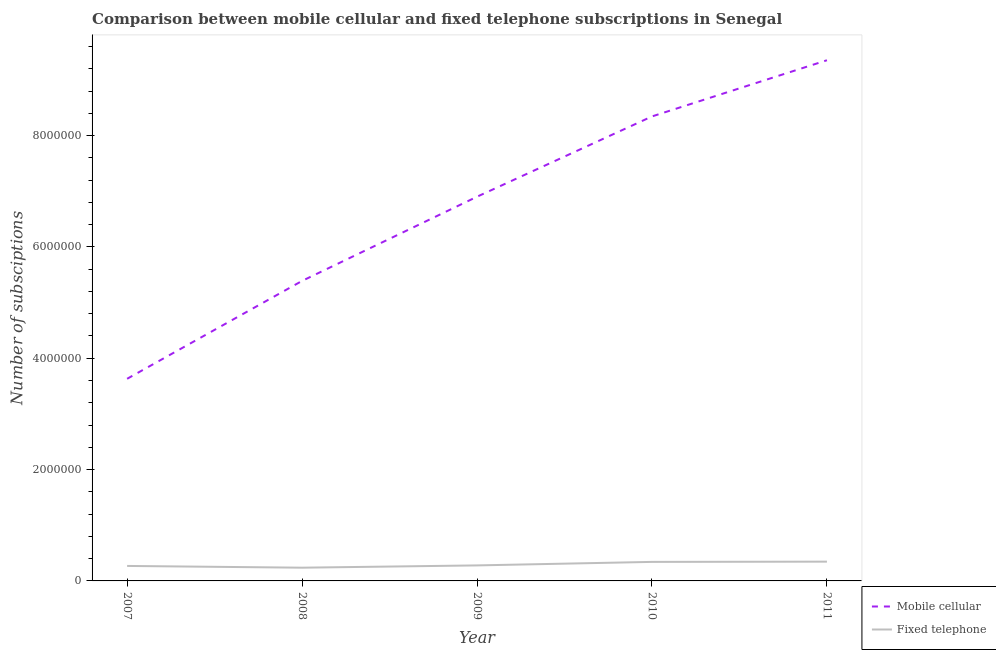How many different coloured lines are there?
Keep it short and to the point. 2. What is the number of fixed telephone subscriptions in 2010?
Give a very brief answer. 3.42e+05. Across all years, what is the maximum number of fixed telephone subscriptions?
Make the answer very short. 3.46e+05. Across all years, what is the minimum number of mobile cellular subscriptions?
Your answer should be very brief. 3.63e+06. In which year was the number of fixed telephone subscriptions minimum?
Your response must be concise. 2008. What is the total number of mobile cellular subscriptions in the graph?
Keep it short and to the point. 3.36e+07. What is the difference between the number of fixed telephone subscriptions in 2007 and that in 2011?
Make the answer very short. -7.73e+04. What is the difference between the number of mobile cellular subscriptions in 2011 and the number of fixed telephone subscriptions in 2009?
Give a very brief answer. 9.07e+06. What is the average number of fixed telephone subscriptions per year?
Give a very brief answer. 2.95e+05. In the year 2008, what is the difference between the number of fixed telephone subscriptions and number of mobile cellular subscriptions?
Give a very brief answer. -5.15e+06. In how many years, is the number of mobile cellular subscriptions greater than 8000000?
Your response must be concise. 2. What is the ratio of the number of mobile cellular subscriptions in 2008 to that in 2010?
Make the answer very short. 0.65. Is the number of mobile cellular subscriptions in 2007 less than that in 2008?
Keep it short and to the point. Yes. Is the difference between the number of mobile cellular subscriptions in 2007 and 2009 greater than the difference between the number of fixed telephone subscriptions in 2007 and 2009?
Your answer should be compact. No. What is the difference between the highest and the second highest number of mobile cellular subscriptions?
Ensure brevity in your answer.  1.01e+06. What is the difference between the highest and the lowest number of mobile cellular subscriptions?
Provide a short and direct response. 5.72e+06. Is the sum of the number of mobile cellular subscriptions in 2009 and 2011 greater than the maximum number of fixed telephone subscriptions across all years?
Your answer should be compact. Yes. Does the number of mobile cellular subscriptions monotonically increase over the years?
Your answer should be very brief. Yes. Is the number of fixed telephone subscriptions strictly greater than the number of mobile cellular subscriptions over the years?
Provide a succinct answer. No. How many lines are there?
Offer a terse response. 2. Does the graph contain any zero values?
Your answer should be very brief. No. Does the graph contain grids?
Give a very brief answer. No. What is the title of the graph?
Give a very brief answer. Comparison between mobile cellular and fixed telephone subscriptions in Senegal. What is the label or title of the X-axis?
Your answer should be compact. Year. What is the label or title of the Y-axis?
Offer a terse response. Number of subsciptions. What is the Number of subsciptions of Mobile cellular in 2007?
Offer a terse response. 3.63e+06. What is the Number of subsciptions in Fixed telephone in 2007?
Offer a very short reply. 2.69e+05. What is the Number of subsciptions of Mobile cellular in 2008?
Offer a very short reply. 5.39e+06. What is the Number of subsciptions of Fixed telephone in 2008?
Your answer should be compact. 2.38e+05. What is the Number of subsciptions of Mobile cellular in 2009?
Keep it short and to the point. 6.90e+06. What is the Number of subsciptions in Fixed telephone in 2009?
Offer a terse response. 2.79e+05. What is the Number of subsciptions in Mobile cellular in 2010?
Provide a short and direct response. 8.34e+06. What is the Number of subsciptions of Fixed telephone in 2010?
Your answer should be compact. 3.42e+05. What is the Number of subsciptions in Mobile cellular in 2011?
Offer a terse response. 9.35e+06. What is the Number of subsciptions of Fixed telephone in 2011?
Provide a succinct answer. 3.46e+05. Across all years, what is the maximum Number of subsciptions in Mobile cellular?
Ensure brevity in your answer.  9.35e+06. Across all years, what is the maximum Number of subsciptions in Fixed telephone?
Offer a terse response. 3.46e+05. Across all years, what is the minimum Number of subsciptions in Mobile cellular?
Your response must be concise. 3.63e+06. Across all years, what is the minimum Number of subsciptions in Fixed telephone?
Make the answer very short. 2.38e+05. What is the total Number of subsciptions in Mobile cellular in the graph?
Give a very brief answer. 3.36e+07. What is the total Number of subsciptions of Fixed telephone in the graph?
Give a very brief answer. 1.47e+06. What is the difference between the Number of subsciptions of Mobile cellular in 2007 and that in 2008?
Ensure brevity in your answer.  -1.76e+06. What is the difference between the Number of subsciptions of Fixed telephone in 2007 and that in 2008?
Make the answer very short. 3.13e+04. What is the difference between the Number of subsciptions of Mobile cellular in 2007 and that in 2009?
Provide a succinct answer. -3.27e+06. What is the difference between the Number of subsciptions in Fixed telephone in 2007 and that in 2009?
Give a very brief answer. -9700. What is the difference between the Number of subsciptions in Mobile cellular in 2007 and that in 2010?
Your answer should be very brief. -4.71e+06. What is the difference between the Number of subsciptions in Fixed telephone in 2007 and that in 2010?
Give a very brief answer. -7.28e+04. What is the difference between the Number of subsciptions in Mobile cellular in 2007 and that in 2011?
Keep it short and to the point. -5.72e+06. What is the difference between the Number of subsciptions of Fixed telephone in 2007 and that in 2011?
Provide a short and direct response. -7.73e+04. What is the difference between the Number of subsciptions in Mobile cellular in 2008 and that in 2009?
Offer a very short reply. -1.51e+06. What is the difference between the Number of subsciptions in Fixed telephone in 2008 and that in 2009?
Provide a short and direct response. -4.10e+04. What is the difference between the Number of subsciptions in Mobile cellular in 2008 and that in 2010?
Ensure brevity in your answer.  -2.95e+06. What is the difference between the Number of subsciptions in Fixed telephone in 2008 and that in 2010?
Offer a very short reply. -1.04e+05. What is the difference between the Number of subsciptions in Mobile cellular in 2008 and that in 2011?
Provide a succinct answer. -3.96e+06. What is the difference between the Number of subsciptions in Fixed telephone in 2008 and that in 2011?
Give a very brief answer. -1.09e+05. What is the difference between the Number of subsciptions in Mobile cellular in 2009 and that in 2010?
Your answer should be very brief. -1.44e+06. What is the difference between the Number of subsciptions of Fixed telephone in 2009 and that in 2010?
Make the answer very short. -6.31e+04. What is the difference between the Number of subsciptions of Mobile cellular in 2009 and that in 2011?
Your answer should be very brief. -2.45e+06. What is the difference between the Number of subsciptions in Fixed telephone in 2009 and that in 2011?
Provide a succinct answer. -6.76e+04. What is the difference between the Number of subsciptions in Mobile cellular in 2010 and that in 2011?
Make the answer very short. -1.01e+06. What is the difference between the Number of subsciptions in Fixed telephone in 2010 and that in 2011?
Offer a terse response. -4549. What is the difference between the Number of subsciptions in Mobile cellular in 2007 and the Number of subsciptions in Fixed telephone in 2008?
Ensure brevity in your answer.  3.39e+06. What is the difference between the Number of subsciptions in Mobile cellular in 2007 and the Number of subsciptions in Fixed telephone in 2009?
Make the answer very short. 3.35e+06. What is the difference between the Number of subsciptions in Mobile cellular in 2007 and the Number of subsciptions in Fixed telephone in 2010?
Ensure brevity in your answer.  3.29e+06. What is the difference between the Number of subsciptions of Mobile cellular in 2007 and the Number of subsciptions of Fixed telephone in 2011?
Your answer should be compact. 3.28e+06. What is the difference between the Number of subsciptions of Mobile cellular in 2008 and the Number of subsciptions of Fixed telephone in 2009?
Provide a succinct answer. 5.11e+06. What is the difference between the Number of subsciptions of Mobile cellular in 2008 and the Number of subsciptions of Fixed telephone in 2010?
Offer a very short reply. 5.05e+06. What is the difference between the Number of subsciptions of Mobile cellular in 2008 and the Number of subsciptions of Fixed telephone in 2011?
Keep it short and to the point. 5.04e+06. What is the difference between the Number of subsciptions of Mobile cellular in 2009 and the Number of subsciptions of Fixed telephone in 2010?
Ensure brevity in your answer.  6.56e+06. What is the difference between the Number of subsciptions in Mobile cellular in 2009 and the Number of subsciptions in Fixed telephone in 2011?
Ensure brevity in your answer.  6.56e+06. What is the difference between the Number of subsciptions of Mobile cellular in 2010 and the Number of subsciptions of Fixed telephone in 2011?
Provide a short and direct response. 8.00e+06. What is the average Number of subsciptions of Mobile cellular per year?
Keep it short and to the point. 6.72e+06. What is the average Number of subsciptions of Fixed telephone per year?
Your answer should be very brief. 2.95e+05. In the year 2007, what is the difference between the Number of subsciptions of Mobile cellular and Number of subsciptions of Fixed telephone?
Provide a short and direct response. 3.36e+06. In the year 2008, what is the difference between the Number of subsciptions in Mobile cellular and Number of subsciptions in Fixed telephone?
Your answer should be compact. 5.15e+06. In the year 2009, what is the difference between the Number of subsciptions in Mobile cellular and Number of subsciptions in Fixed telephone?
Ensure brevity in your answer.  6.62e+06. In the year 2010, what is the difference between the Number of subsciptions of Mobile cellular and Number of subsciptions of Fixed telephone?
Ensure brevity in your answer.  8.00e+06. In the year 2011, what is the difference between the Number of subsciptions in Mobile cellular and Number of subsciptions in Fixed telephone?
Offer a terse response. 9.01e+06. What is the ratio of the Number of subsciptions of Mobile cellular in 2007 to that in 2008?
Your answer should be very brief. 0.67. What is the ratio of the Number of subsciptions in Fixed telephone in 2007 to that in 2008?
Give a very brief answer. 1.13. What is the ratio of the Number of subsciptions of Mobile cellular in 2007 to that in 2009?
Your answer should be very brief. 0.53. What is the ratio of the Number of subsciptions in Fixed telephone in 2007 to that in 2009?
Offer a very short reply. 0.97. What is the ratio of the Number of subsciptions of Mobile cellular in 2007 to that in 2010?
Keep it short and to the point. 0.44. What is the ratio of the Number of subsciptions of Fixed telephone in 2007 to that in 2010?
Keep it short and to the point. 0.79. What is the ratio of the Number of subsciptions in Mobile cellular in 2007 to that in 2011?
Give a very brief answer. 0.39. What is the ratio of the Number of subsciptions in Fixed telephone in 2007 to that in 2011?
Your answer should be very brief. 0.78. What is the ratio of the Number of subsciptions of Mobile cellular in 2008 to that in 2009?
Your answer should be very brief. 0.78. What is the ratio of the Number of subsciptions in Fixed telephone in 2008 to that in 2009?
Keep it short and to the point. 0.85. What is the ratio of the Number of subsciptions in Mobile cellular in 2008 to that in 2010?
Ensure brevity in your answer.  0.65. What is the ratio of the Number of subsciptions of Fixed telephone in 2008 to that in 2010?
Your response must be concise. 0.7. What is the ratio of the Number of subsciptions in Mobile cellular in 2008 to that in 2011?
Give a very brief answer. 0.58. What is the ratio of the Number of subsciptions of Fixed telephone in 2008 to that in 2011?
Provide a short and direct response. 0.69. What is the ratio of the Number of subsciptions in Mobile cellular in 2009 to that in 2010?
Keep it short and to the point. 0.83. What is the ratio of the Number of subsciptions of Fixed telephone in 2009 to that in 2010?
Your response must be concise. 0.82. What is the ratio of the Number of subsciptions in Mobile cellular in 2009 to that in 2011?
Offer a very short reply. 0.74. What is the ratio of the Number of subsciptions in Fixed telephone in 2009 to that in 2011?
Give a very brief answer. 0.8. What is the ratio of the Number of subsciptions of Mobile cellular in 2010 to that in 2011?
Your response must be concise. 0.89. What is the ratio of the Number of subsciptions of Fixed telephone in 2010 to that in 2011?
Your answer should be very brief. 0.99. What is the difference between the highest and the second highest Number of subsciptions in Mobile cellular?
Provide a succinct answer. 1.01e+06. What is the difference between the highest and the second highest Number of subsciptions in Fixed telephone?
Your response must be concise. 4549. What is the difference between the highest and the lowest Number of subsciptions of Mobile cellular?
Ensure brevity in your answer.  5.72e+06. What is the difference between the highest and the lowest Number of subsciptions of Fixed telephone?
Offer a terse response. 1.09e+05. 